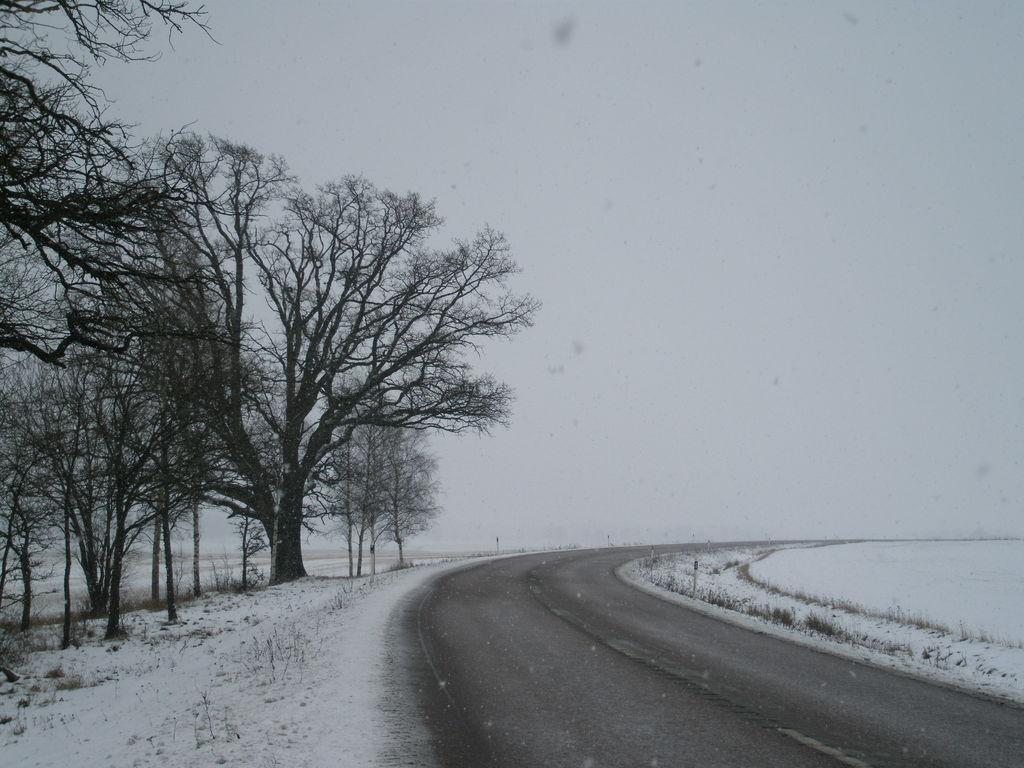How would you summarize this image in a sentence or two? On the left there are trees, plants and snow. In the center of the picture it is road. On the right there is snow. Sky is cloudy. 